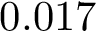<formula> <loc_0><loc_0><loc_500><loc_500>0 . 0 1 7 \</formula> 